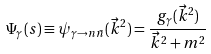<formula> <loc_0><loc_0><loc_500><loc_500>\Psi _ { \gamma } ( s ) \equiv \psi _ { \gamma \to n \bar { n } } ( \vec { k } ^ { 2 } ) = \frac { g _ { \gamma } ( \vec { k } ^ { 2 } ) } { \vec { k } ^ { 2 } + m ^ { 2 } }</formula> 